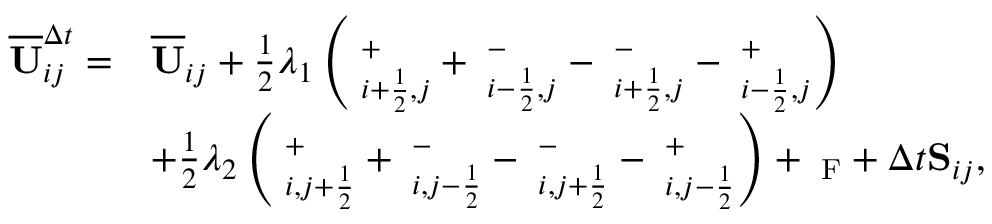<formula> <loc_0><loc_0><loc_500><loc_500>\begin{array} { r l } { \overline { U } _ { i j } ^ { \Delta t } = } & { \overline { U } _ { i j } + \frac { 1 } { 2 } \lambda _ { 1 } \left ( { \Pi } _ { i + \frac { 1 } { 2 } , j } ^ { + } + { \Pi } _ { i - \frac { 1 } { 2 } , j } ^ { - } - { \Pi } _ { i + \frac { 1 } { 2 } , j } ^ { - } - { \Pi } _ { i - \frac { 1 } { 2 } , j } ^ { + } \right ) } \\ & { + \frac { 1 } { 2 } \lambda _ { 2 } \left ( { \Pi } _ { i , j + \frac { 1 } { 2 } } ^ { + } + { \Pi } _ { i , j - \frac { 1 } { 2 } } ^ { - } - { \Pi } _ { i , j + \frac { 1 } { 2 } } ^ { - } - { \Pi } _ { i , j - \frac { 1 } { 2 } } ^ { + } \right ) + { \Pi } _ { F } + \Delta t { S } _ { i j } , } \end{array}</formula> 